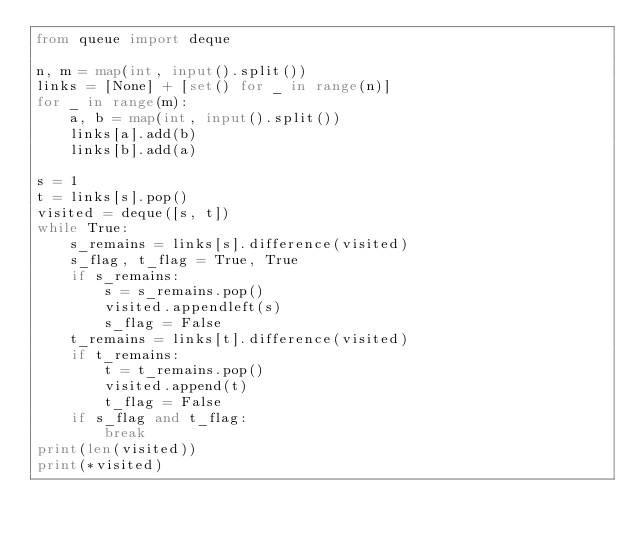<code> <loc_0><loc_0><loc_500><loc_500><_Python_>from queue import deque

n, m = map(int, input().split())
links = [None] + [set() for _ in range(n)]
for _ in range(m):
    a, b = map(int, input().split())
    links[a].add(b)
    links[b].add(a)

s = 1
t = links[s].pop()
visited = deque([s, t])
while True:
    s_remains = links[s].difference(visited)
    s_flag, t_flag = True, True
    if s_remains:
        s = s_remains.pop()
        visited.appendleft(s)
        s_flag = False
    t_remains = links[t].difference(visited)
    if t_remains:
        t = t_remains.pop()
        visited.append(t)
        t_flag = False
    if s_flag and t_flag:
        break
print(len(visited))
print(*visited)
</code> 